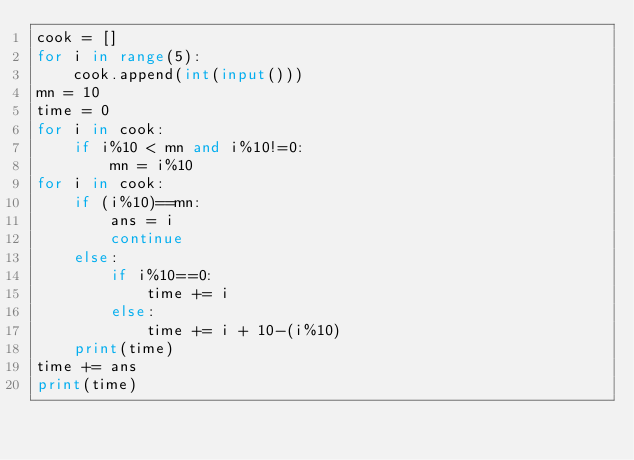Convert code to text. <code><loc_0><loc_0><loc_500><loc_500><_Python_>cook = []
for i in range(5):
    cook.append(int(input()))
mn = 10
time = 0
for i in cook:
    if i%10 < mn and i%10!=0:
        mn = i%10
for i in cook:
    if (i%10)==mn:
        ans = i
        continue
    else:
        if i%10==0:
            time += i
        else:
            time += i + 10-(i%10)
    print(time)
time += ans
print(time)</code> 